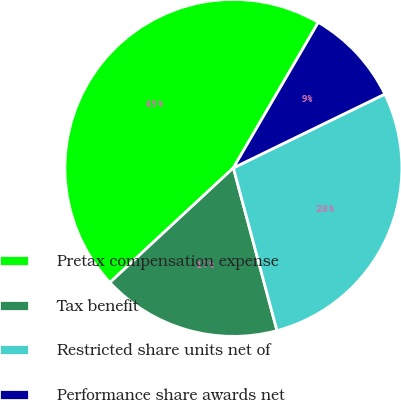Convert chart. <chart><loc_0><loc_0><loc_500><loc_500><pie_chart><fcel>Pretax compensation expense<fcel>Tax benefit<fcel>Restricted share units net of<fcel>Performance share awards net<nl><fcel>45.31%<fcel>17.26%<fcel>28.05%<fcel>9.38%<nl></chart> 